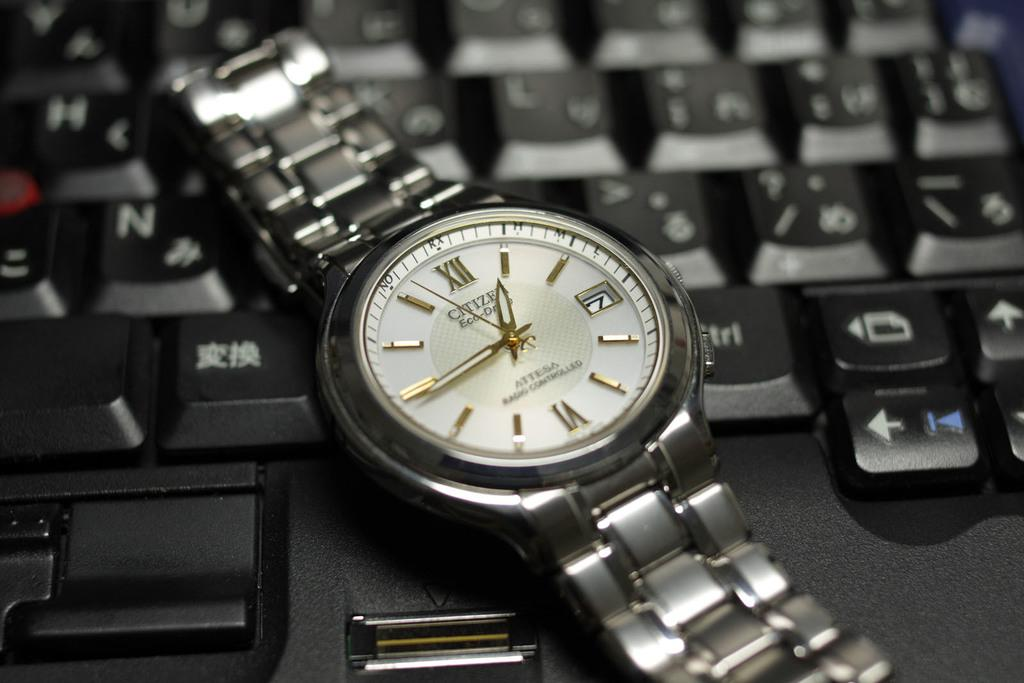<image>
Create a compact narrative representing the image presented. A Citiizen Eco-Drive watch stretched out on a keyboard. 